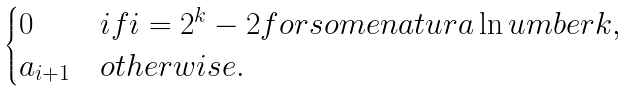Convert formula to latex. <formula><loc_0><loc_0><loc_500><loc_500>\begin{cases} 0 & i f i = 2 ^ { k } - 2 f o r s o m e n a t u r a \ln u m b e r k , \\ a _ { i + 1 } & o t h e r w i s e . \end{cases}</formula> 